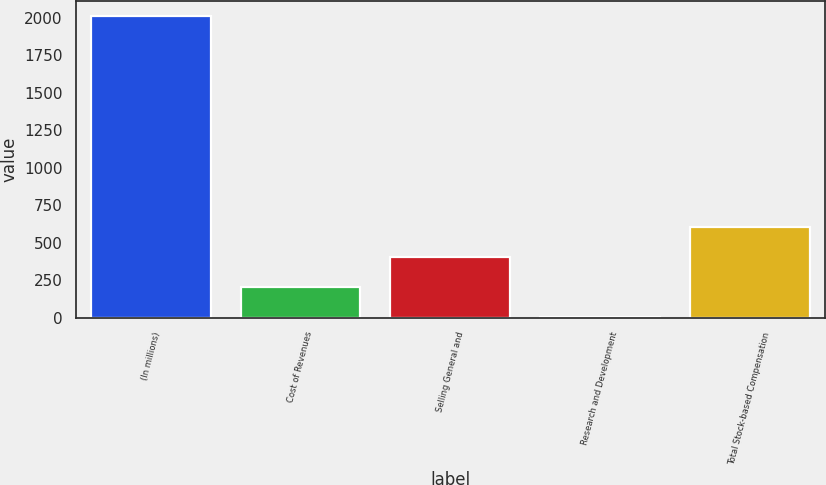<chart> <loc_0><loc_0><loc_500><loc_500><bar_chart><fcel>(In millions)<fcel>Cost of Revenues<fcel>Selling General and<fcel>Research and Development<fcel>Total Stock-based Compensation<nl><fcel>2009<fcel>202.79<fcel>403.48<fcel>2.1<fcel>604.17<nl></chart> 